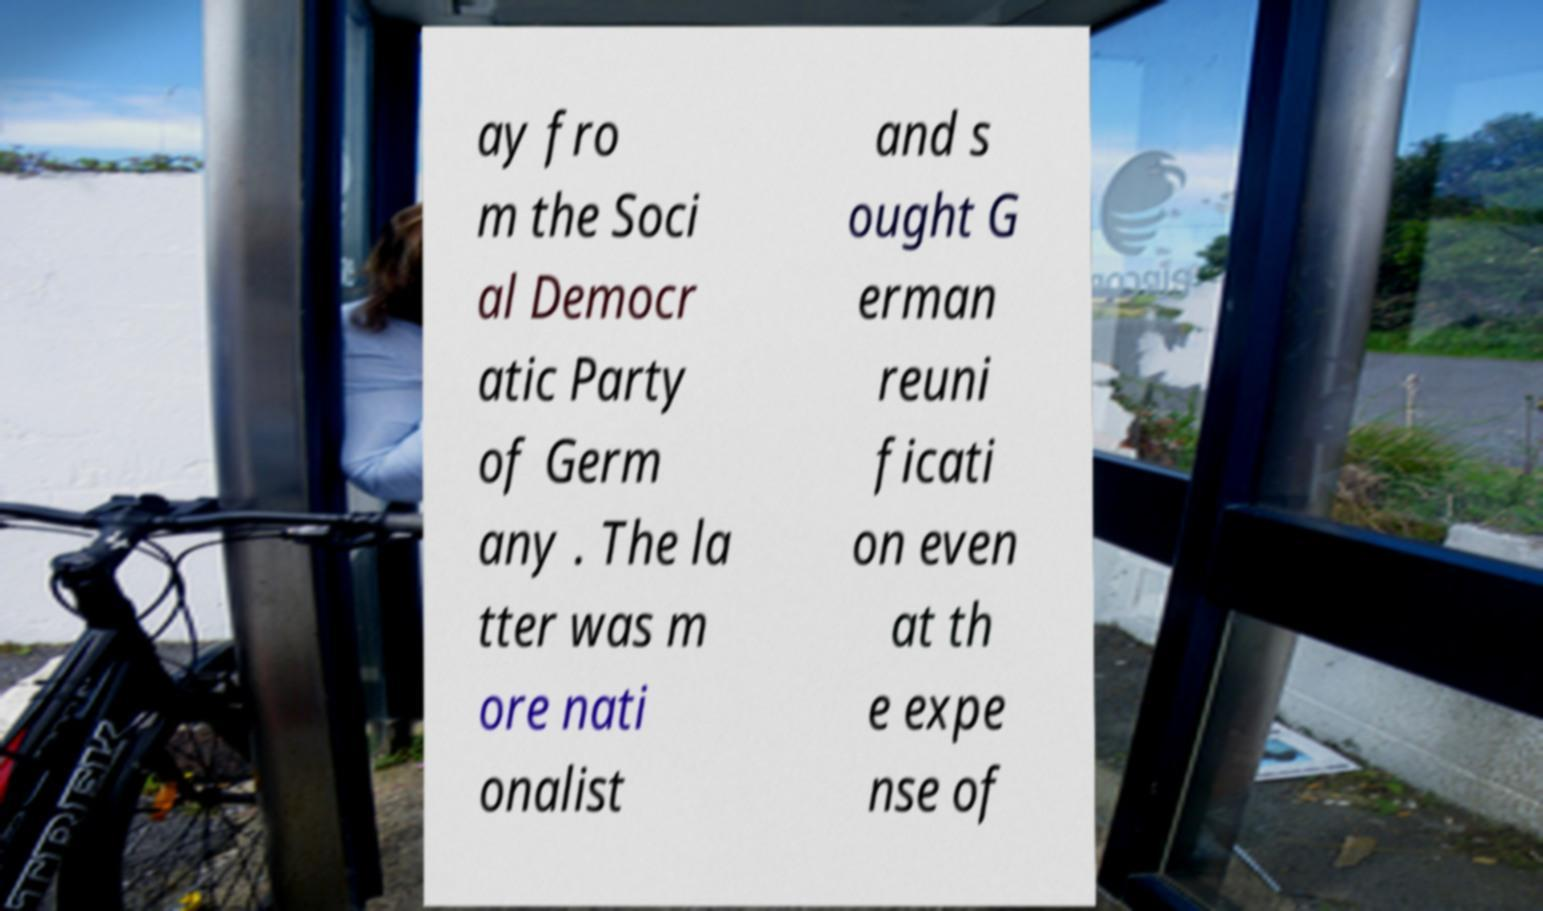Please identify and transcribe the text found in this image. ay fro m the Soci al Democr atic Party of Germ any . The la tter was m ore nati onalist and s ought G erman reuni ficati on even at th e expe nse of 